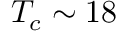<formula> <loc_0><loc_0><loc_500><loc_500>T _ { c } \sim 1 8</formula> 